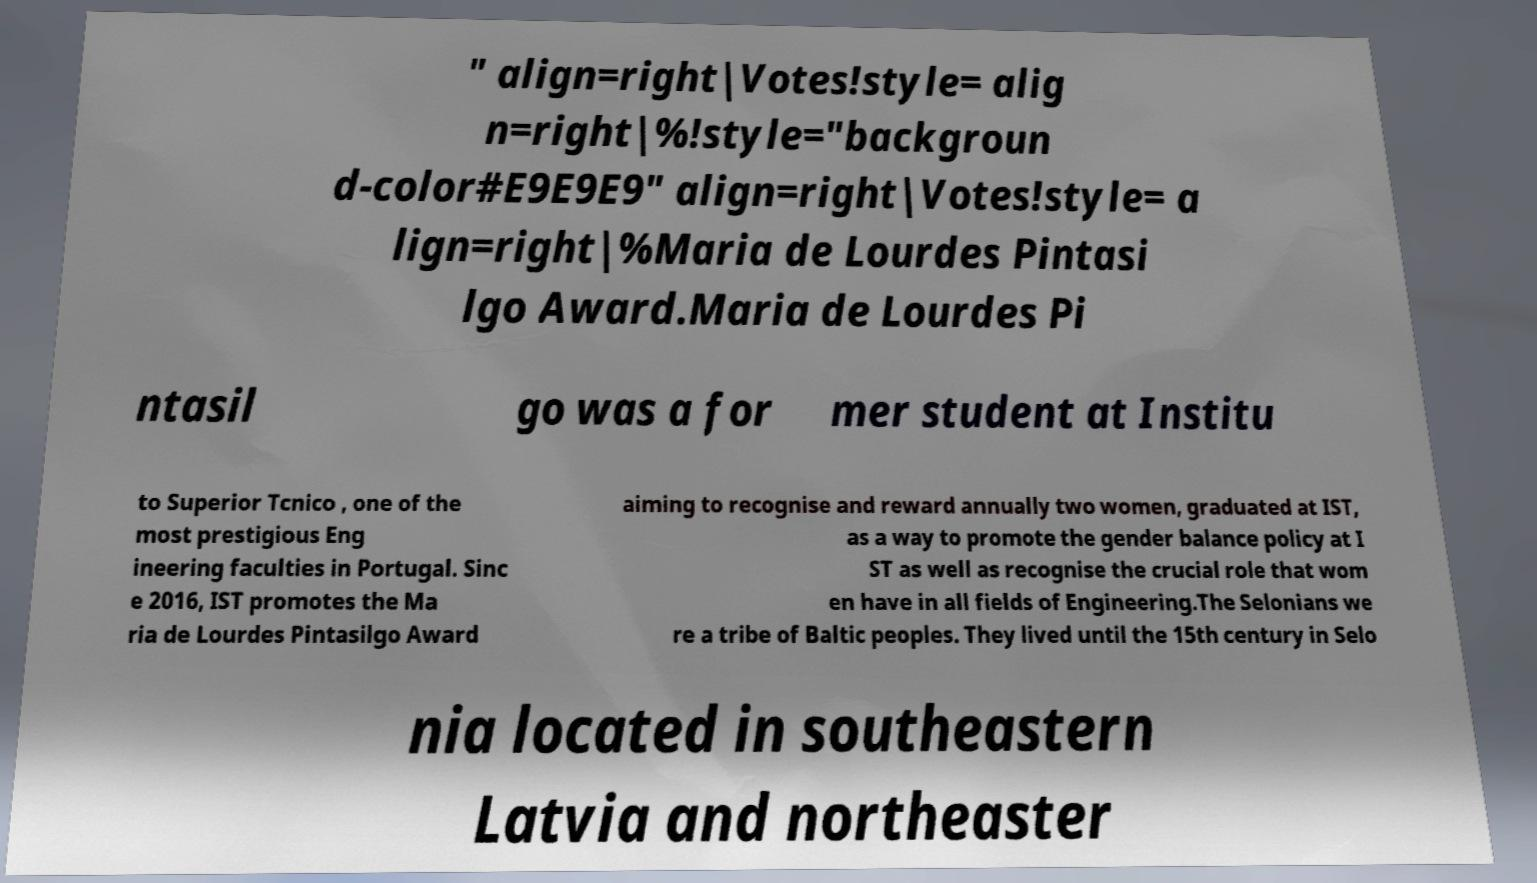Could you assist in decoding the text presented in this image and type it out clearly? " align=right|Votes!style= alig n=right|%!style="backgroun d-color#E9E9E9" align=right|Votes!style= a lign=right|%Maria de Lourdes Pintasi lgo Award.Maria de Lourdes Pi ntasil go was a for mer student at Institu to Superior Tcnico , one of the most prestigious Eng ineering faculties in Portugal. Sinc e 2016, IST promotes the Ma ria de Lourdes Pintasilgo Award aiming to recognise and reward annually two women, graduated at IST, as a way to promote the gender balance policy at I ST as well as recognise the crucial role that wom en have in all fields of Engineering.The Selonians we re a tribe of Baltic peoples. They lived until the 15th century in Selo nia located in southeastern Latvia and northeaster 